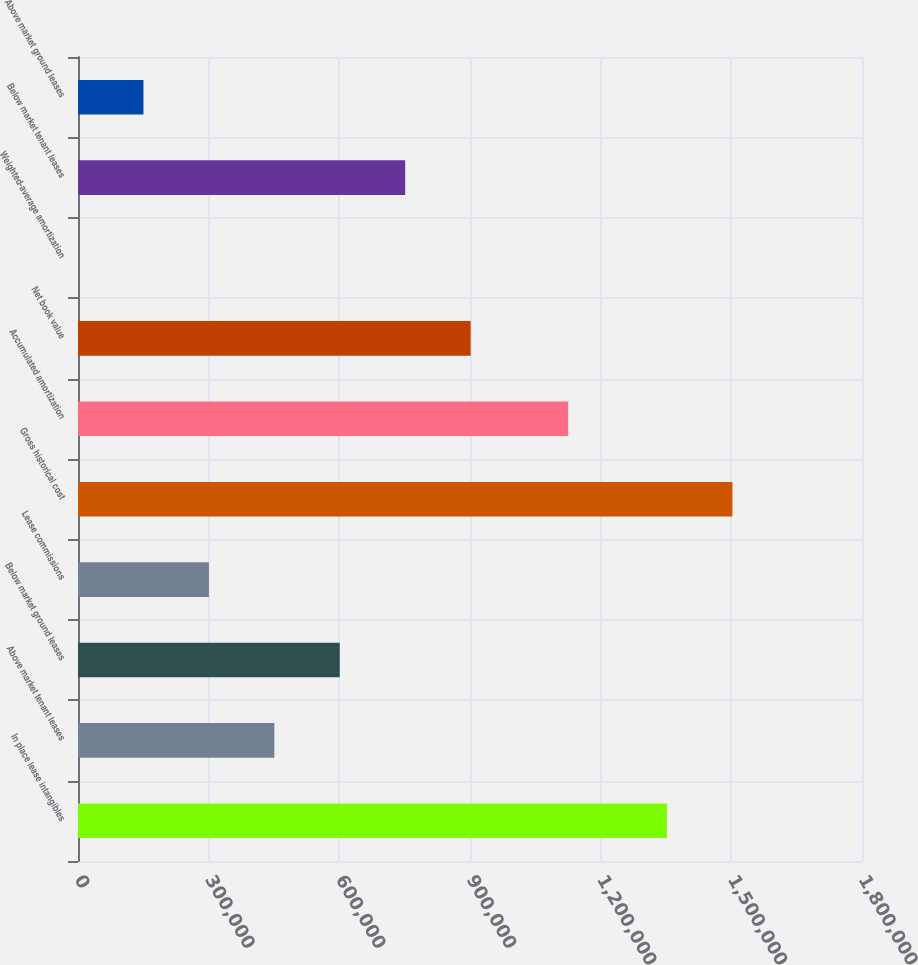Convert chart to OTSL. <chart><loc_0><loc_0><loc_500><loc_500><bar_chart><fcel>In place lease intangibles<fcel>Above market tenant leases<fcel>Below market ground leases<fcel>Lease commissions<fcel>Gross historical cost<fcel>Accumulated amortization<fcel>Net book value<fcel>Weighted-average amortization<fcel>Below market tenant leases<fcel>Above market ground leases<nl><fcel>1.35214e+06<fcel>450752<fcel>600997<fcel>300506<fcel>1.50247e+06<fcel>1.12544e+06<fcel>901489<fcel>15.1<fcel>751243<fcel>150261<nl></chart> 